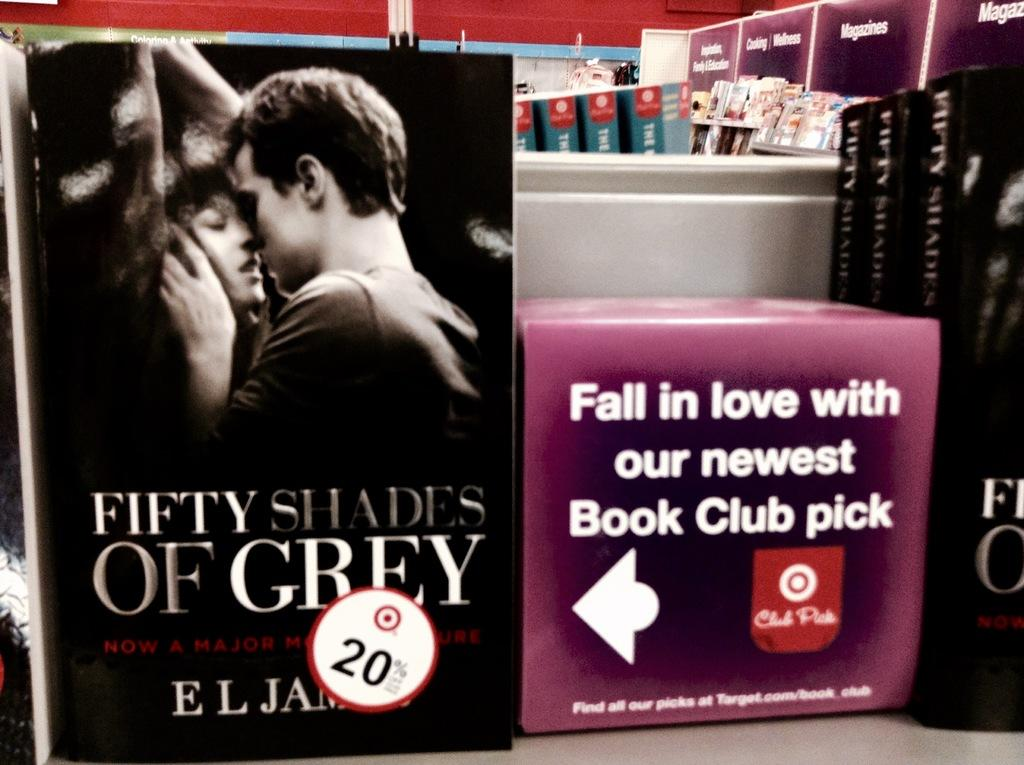Provide a one-sentence caption for the provided image. A book called Fifty Shades of Grey with a 20% off sticker. 